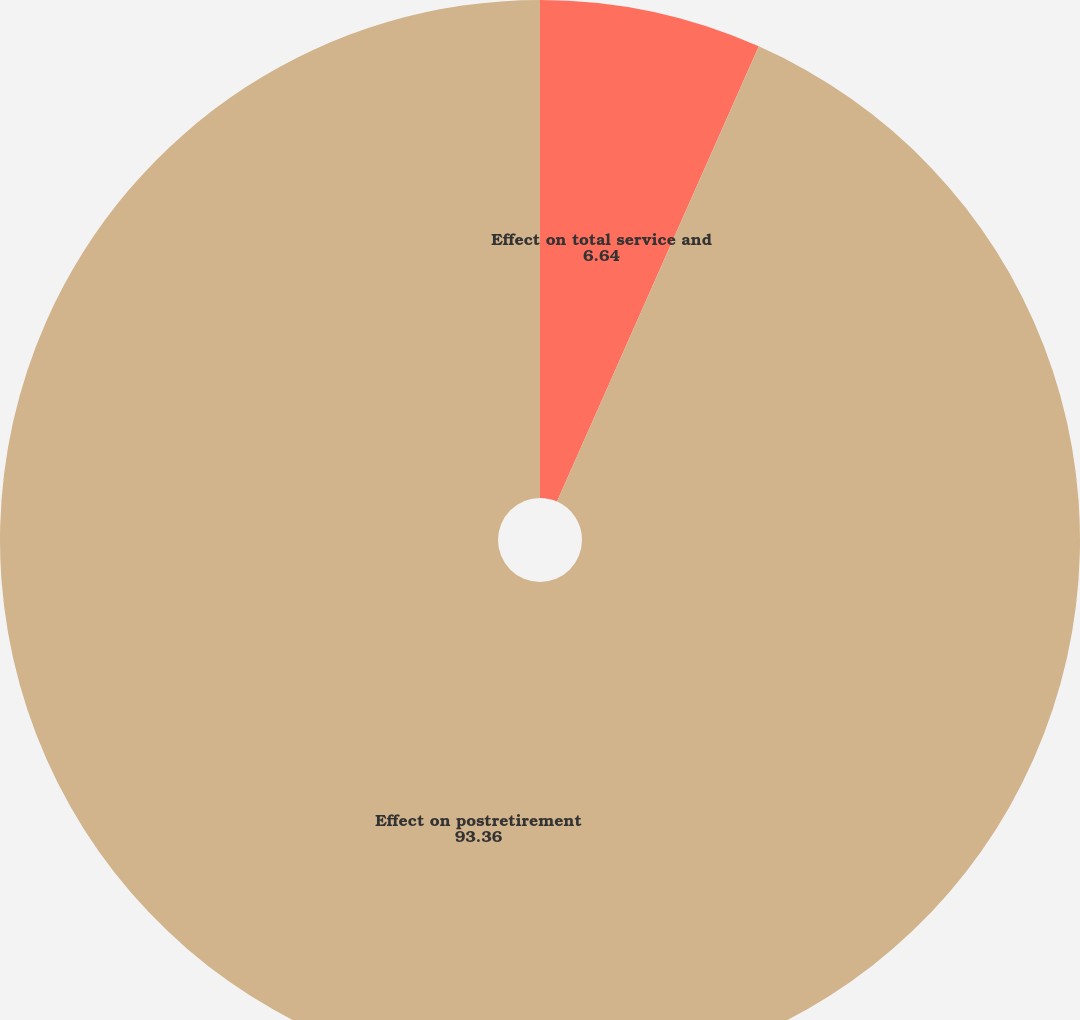Convert chart. <chart><loc_0><loc_0><loc_500><loc_500><pie_chart><fcel>Effect on total service and<fcel>Effect on postretirement<nl><fcel>6.64%<fcel>93.36%<nl></chart> 